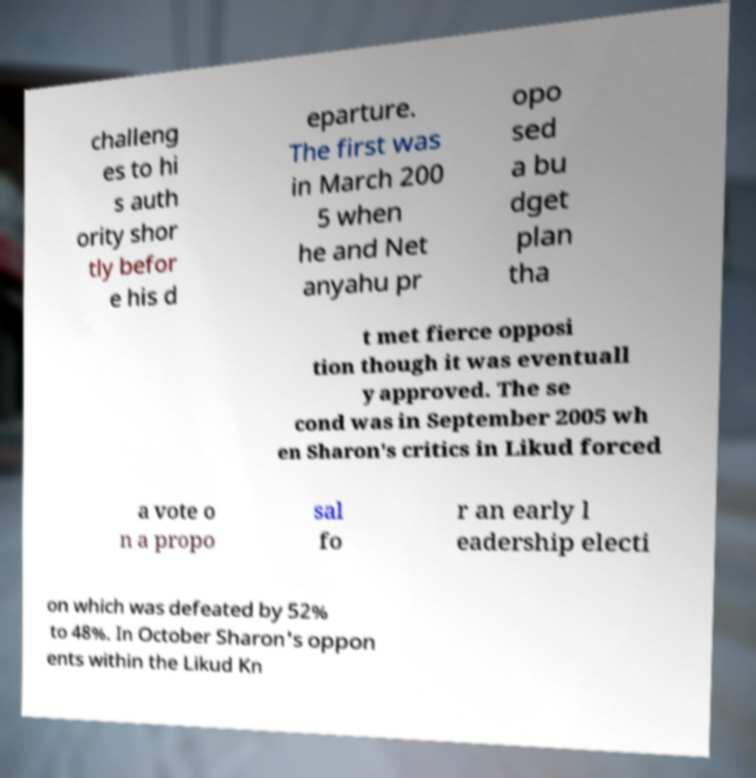For documentation purposes, I need the text within this image transcribed. Could you provide that? challeng es to hi s auth ority shor tly befor e his d eparture. The first was in March 200 5 when he and Net anyahu pr opo sed a bu dget plan tha t met fierce opposi tion though it was eventuall y approved. The se cond was in September 2005 wh en Sharon's critics in Likud forced a vote o n a propo sal fo r an early l eadership electi on which was defeated by 52% to 48%. In October Sharon's oppon ents within the Likud Kn 